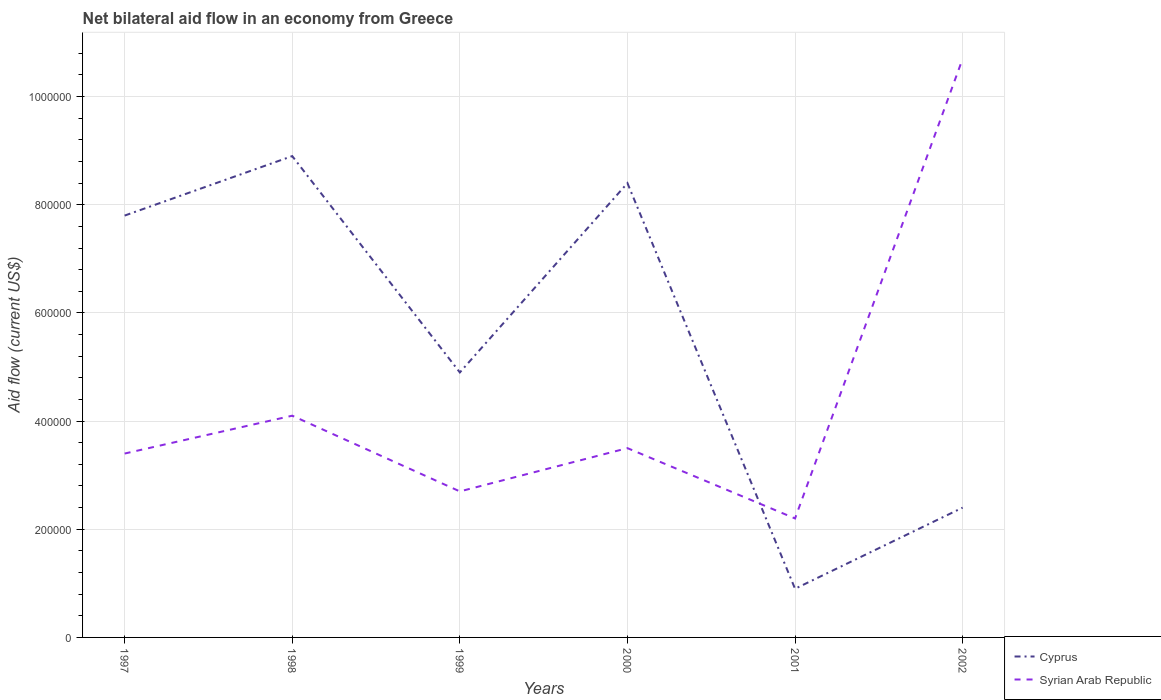Does the line corresponding to Syrian Arab Republic intersect with the line corresponding to Cyprus?
Your answer should be very brief. Yes. Is the number of lines equal to the number of legend labels?
Provide a short and direct response. Yes. Across all years, what is the maximum net bilateral aid flow in Cyprus?
Offer a very short reply. 9.00e+04. In which year was the net bilateral aid flow in Cyprus maximum?
Your answer should be compact. 2001. What is the total net bilateral aid flow in Cyprus in the graph?
Offer a terse response. -1.50e+05. What is the difference between the highest and the second highest net bilateral aid flow in Cyprus?
Your answer should be compact. 8.00e+05. What is the difference between the highest and the lowest net bilateral aid flow in Syrian Arab Republic?
Give a very brief answer. 1. Are the values on the major ticks of Y-axis written in scientific E-notation?
Provide a short and direct response. No. Does the graph contain grids?
Provide a short and direct response. Yes. What is the title of the graph?
Your answer should be very brief. Net bilateral aid flow in an economy from Greece. Does "Central Europe" appear as one of the legend labels in the graph?
Your response must be concise. No. What is the label or title of the Y-axis?
Offer a very short reply. Aid flow (current US$). What is the Aid flow (current US$) in Cyprus in 1997?
Keep it short and to the point. 7.80e+05. What is the Aid flow (current US$) of Cyprus in 1998?
Keep it short and to the point. 8.90e+05. What is the Aid flow (current US$) of Syrian Arab Republic in 1998?
Offer a terse response. 4.10e+05. What is the Aid flow (current US$) of Cyprus in 1999?
Make the answer very short. 4.90e+05. What is the Aid flow (current US$) of Cyprus in 2000?
Provide a succinct answer. 8.40e+05. What is the Aid flow (current US$) in Syrian Arab Republic in 2002?
Make the answer very short. 1.07e+06. Across all years, what is the maximum Aid flow (current US$) in Cyprus?
Offer a terse response. 8.90e+05. Across all years, what is the maximum Aid flow (current US$) in Syrian Arab Republic?
Provide a succinct answer. 1.07e+06. What is the total Aid flow (current US$) of Cyprus in the graph?
Your response must be concise. 3.33e+06. What is the total Aid flow (current US$) in Syrian Arab Republic in the graph?
Your answer should be compact. 2.66e+06. What is the difference between the Aid flow (current US$) of Cyprus in 1997 and that in 1999?
Give a very brief answer. 2.90e+05. What is the difference between the Aid flow (current US$) in Syrian Arab Republic in 1997 and that in 1999?
Give a very brief answer. 7.00e+04. What is the difference between the Aid flow (current US$) in Syrian Arab Republic in 1997 and that in 2000?
Make the answer very short. -10000. What is the difference between the Aid flow (current US$) of Cyprus in 1997 and that in 2001?
Provide a succinct answer. 6.90e+05. What is the difference between the Aid flow (current US$) of Cyprus in 1997 and that in 2002?
Your answer should be very brief. 5.40e+05. What is the difference between the Aid flow (current US$) of Syrian Arab Republic in 1997 and that in 2002?
Provide a short and direct response. -7.30e+05. What is the difference between the Aid flow (current US$) of Cyprus in 1998 and that in 1999?
Your answer should be compact. 4.00e+05. What is the difference between the Aid flow (current US$) of Syrian Arab Republic in 1998 and that in 1999?
Provide a short and direct response. 1.40e+05. What is the difference between the Aid flow (current US$) of Cyprus in 1998 and that in 2000?
Offer a very short reply. 5.00e+04. What is the difference between the Aid flow (current US$) of Cyprus in 1998 and that in 2002?
Provide a short and direct response. 6.50e+05. What is the difference between the Aid flow (current US$) of Syrian Arab Republic in 1998 and that in 2002?
Ensure brevity in your answer.  -6.60e+05. What is the difference between the Aid flow (current US$) in Cyprus in 1999 and that in 2000?
Your response must be concise. -3.50e+05. What is the difference between the Aid flow (current US$) in Cyprus in 1999 and that in 2001?
Give a very brief answer. 4.00e+05. What is the difference between the Aid flow (current US$) in Cyprus in 1999 and that in 2002?
Offer a very short reply. 2.50e+05. What is the difference between the Aid flow (current US$) of Syrian Arab Republic in 1999 and that in 2002?
Provide a short and direct response. -8.00e+05. What is the difference between the Aid flow (current US$) in Cyprus in 2000 and that in 2001?
Your response must be concise. 7.50e+05. What is the difference between the Aid flow (current US$) in Syrian Arab Republic in 2000 and that in 2001?
Keep it short and to the point. 1.30e+05. What is the difference between the Aid flow (current US$) of Cyprus in 2000 and that in 2002?
Offer a terse response. 6.00e+05. What is the difference between the Aid flow (current US$) in Syrian Arab Republic in 2000 and that in 2002?
Your answer should be very brief. -7.20e+05. What is the difference between the Aid flow (current US$) in Syrian Arab Republic in 2001 and that in 2002?
Ensure brevity in your answer.  -8.50e+05. What is the difference between the Aid flow (current US$) in Cyprus in 1997 and the Aid flow (current US$) in Syrian Arab Republic in 1999?
Offer a terse response. 5.10e+05. What is the difference between the Aid flow (current US$) in Cyprus in 1997 and the Aid flow (current US$) in Syrian Arab Republic in 2001?
Your response must be concise. 5.60e+05. What is the difference between the Aid flow (current US$) in Cyprus in 1997 and the Aid flow (current US$) in Syrian Arab Republic in 2002?
Offer a terse response. -2.90e+05. What is the difference between the Aid flow (current US$) of Cyprus in 1998 and the Aid flow (current US$) of Syrian Arab Republic in 1999?
Your response must be concise. 6.20e+05. What is the difference between the Aid flow (current US$) of Cyprus in 1998 and the Aid flow (current US$) of Syrian Arab Republic in 2000?
Provide a short and direct response. 5.40e+05. What is the difference between the Aid flow (current US$) in Cyprus in 1998 and the Aid flow (current US$) in Syrian Arab Republic in 2001?
Keep it short and to the point. 6.70e+05. What is the difference between the Aid flow (current US$) of Cyprus in 1999 and the Aid flow (current US$) of Syrian Arab Republic in 2001?
Offer a terse response. 2.70e+05. What is the difference between the Aid flow (current US$) of Cyprus in 1999 and the Aid flow (current US$) of Syrian Arab Republic in 2002?
Offer a terse response. -5.80e+05. What is the difference between the Aid flow (current US$) in Cyprus in 2000 and the Aid flow (current US$) in Syrian Arab Republic in 2001?
Keep it short and to the point. 6.20e+05. What is the difference between the Aid flow (current US$) of Cyprus in 2001 and the Aid flow (current US$) of Syrian Arab Republic in 2002?
Offer a terse response. -9.80e+05. What is the average Aid flow (current US$) in Cyprus per year?
Offer a very short reply. 5.55e+05. What is the average Aid flow (current US$) in Syrian Arab Republic per year?
Your answer should be very brief. 4.43e+05. In the year 1999, what is the difference between the Aid flow (current US$) of Cyprus and Aid flow (current US$) of Syrian Arab Republic?
Your answer should be very brief. 2.20e+05. In the year 2002, what is the difference between the Aid flow (current US$) of Cyprus and Aid flow (current US$) of Syrian Arab Republic?
Ensure brevity in your answer.  -8.30e+05. What is the ratio of the Aid flow (current US$) in Cyprus in 1997 to that in 1998?
Provide a succinct answer. 0.88. What is the ratio of the Aid flow (current US$) of Syrian Arab Republic in 1997 to that in 1998?
Give a very brief answer. 0.83. What is the ratio of the Aid flow (current US$) of Cyprus in 1997 to that in 1999?
Make the answer very short. 1.59. What is the ratio of the Aid flow (current US$) of Syrian Arab Republic in 1997 to that in 1999?
Make the answer very short. 1.26. What is the ratio of the Aid flow (current US$) of Cyprus in 1997 to that in 2000?
Make the answer very short. 0.93. What is the ratio of the Aid flow (current US$) of Syrian Arab Republic in 1997 to that in 2000?
Make the answer very short. 0.97. What is the ratio of the Aid flow (current US$) of Cyprus in 1997 to that in 2001?
Keep it short and to the point. 8.67. What is the ratio of the Aid flow (current US$) of Syrian Arab Republic in 1997 to that in 2001?
Your response must be concise. 1.55. What is the ratio of the Aid flow (current US$) of Syrian Arab Republic in 1997 to that in 2002?
Give a very brief answer. 0.32. What is the ratio of the Aid flow (current US$) in Cyprus in 1998 to that in 1999?
Your response must be concise. 1.82. What is the ratio of the Aid flow (current US$) of Syrian Arab Republic in 1998 to that in 1999?
Keep it short and to the point. 1.52. What is the ratio of the Aid flow (current US$) in Cyprus in 1998 to that in 2000?
Make the answer very short. 1.06. What is the ratio of the Aid flow (current US$) in Syrian Arab Republic in 1998 to that in 2000?
Make the answer very short. 1.17. What is the ratio of the Aid flow (current US$) of Cyprus in 1998 to that in 2001?
Make the answer very short. 9.89. What is the ratio of the Aid flow (current US$) of Syrian Arab Republic in 1998 to that in 2001?
Your response must be concise. 1.86. What is the ratio of the Aid flow (current US$) of Cyprus in 1998 to that in 2002?
Your answer should be compact. 3.71. What is the ratio of the Aid flow (current US$) in Syrian Arab Republic in 1998 to that in 2002?
Keep it short and to the point. 0.38. What is the ratio of the Aid flow (current US$) of Cyprus in 1999 to that in 2000?
Make the answer very short. 0.58. What is the ratio of the Aid flow (current US$) in Syrian Arab Republic in 1999 to that in 2000?
Keep it short and to the point. 0.77. What is the ratio of the Aid flow (current US$) in Cyprus in 1999 to that in 2001?
Keep it short and to the point. 5.44. What is the ratio of the Aid flow (current US$) of Syrian Arab Republic in 1999 to that in 2001?
Your answer should be very brief. 1.23. What is the ratio of the Aid flow (current US$) of Cyprus in 1999 to that in 2002?
Keep it short and to the point. 2.04. What is the ratio of the Aid flow (current US$) in Syrian Arab Republic in 1999 to that in 2002?
Provide a succinct answer. 0.25. What is the ratio of the Aid flow (current US$) of Cyprus in 2000 to that in 2001?
Give a very brief answer. 9.33. What is the ratio of the Aid flow (current US$) in Syrian Arab Republic in 2000 to that in 2001?
Offer a terse response. 1.59. What is the ratio of the Aid flow (current US$) of Syrian Arab Republic in 2000 to that in 2002?
Your response must be concise. 0.33. What is the ratio of the Aid flow (current US$) of Cyprus in 2001 to that in 2002?
Your answer should be compact. 0.38. What is the ratio of the Aid flow (current US$) in Syrian Arab Republic in 2001 to that in 2002?
Provide a succinct answer. 0.21. What is the difference between the highest and the second highest Aid flow (current US$) of Cyprus?
Make the answer very short. 5.00e+04. What is the difference between the highest and the second highest Aid flow (current US$) in Syrian Arab Republic?
Keep it short and to the point. 6.60e+05. What is the difference between the highest and the lowest Aid flow (current US$) of Syrian Arab Republic?
Keep it short and to the point. 8.50e+05. 